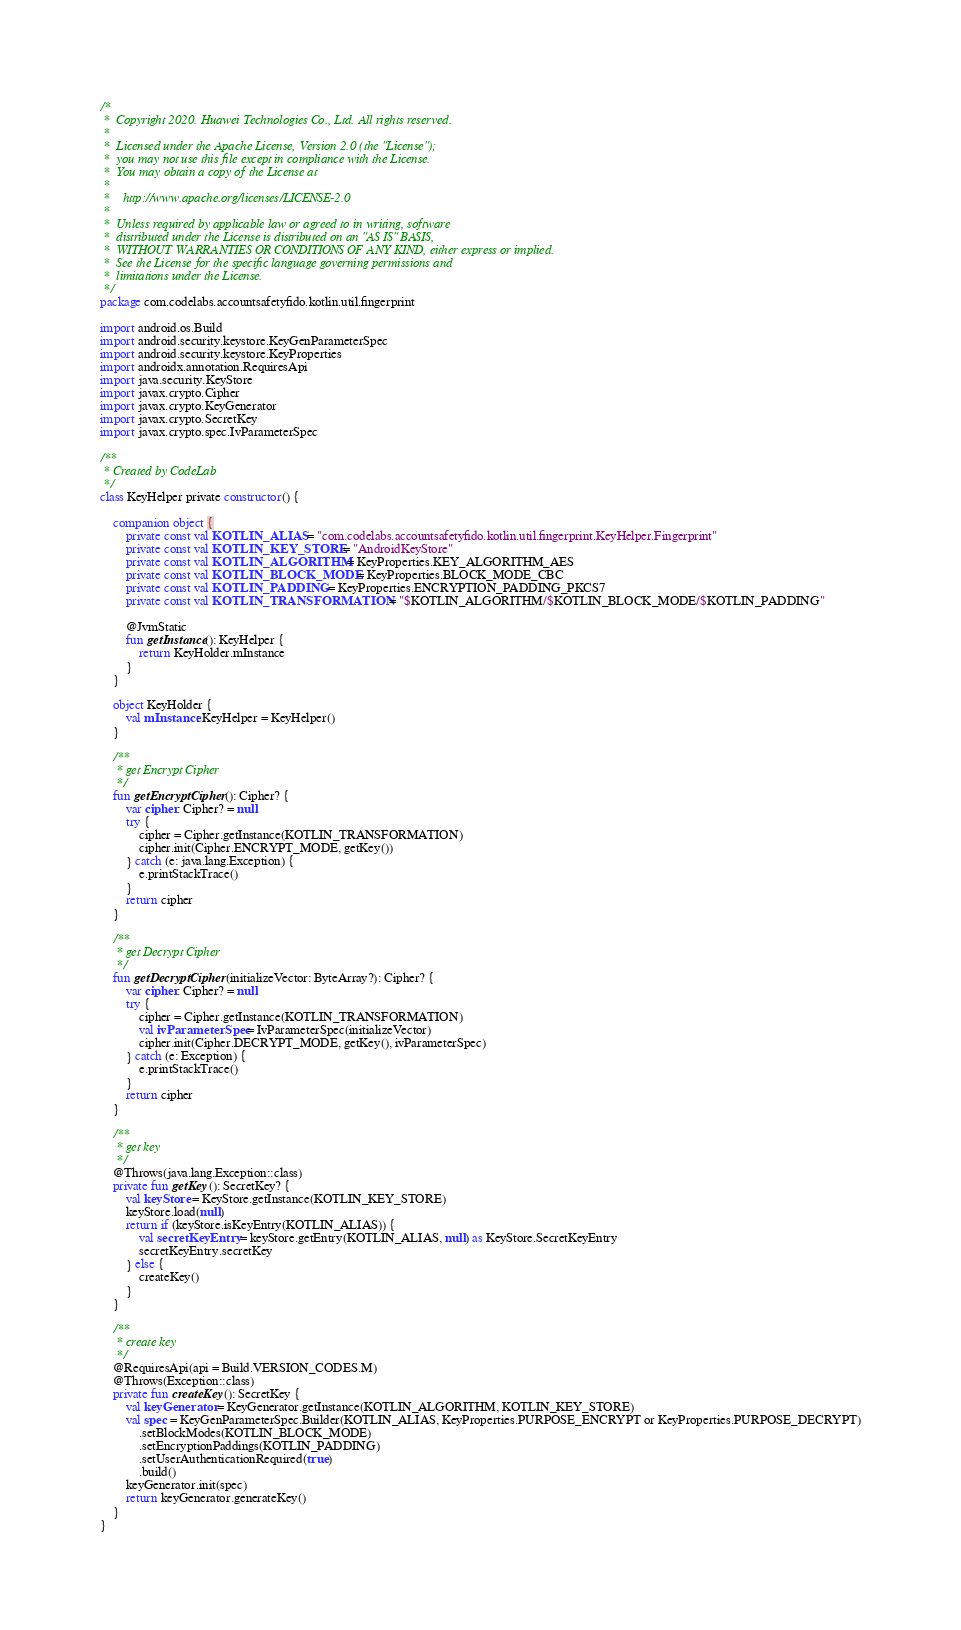Convert code to text. <code><loc_0><loc_0><loc_500><loc_500><_Kotlin_>/*
 *  Copyright 2020. Huawei Technologies Co., Ltd. All rights reserved.
 *
 *  Licensed under the Apache License, Version 2.0 (the "License");
 *  you may not use this file except in compliance with the License.
 *  You may obtain a copy of the License at
 *
 *    http://www.apache.org/licenses/LICENSE-2.0
 *
 *  Unless required by applicable law or agreed to in writing, software
 *  distributed under the License is distributed on an "AS IS" BASIS,
 *  WITHOUT WARRANTIES OR CONDITIONS OF ANY KIND, either express or implied.
 *  See the License for the specific language governing permissions and
 *  limitations under the License.
 */
package com.codelabs.accountsafetyfido.kotlin.util.fingerprint

import android.os.Build
import android.security.keystore.KeyGenParameterSpec
import android.security.keystore.KeyProperties
import androidx.annotation.RequiresApi
import java.security.KeyStore
import javax.crypto.Cipher
import javax.crypto.KeyGenerator
import javax.crypto.SecretKey
import javax.crypto.spec.IvParameterSpec

/**
 * Created by CodeLab
 */
class KeyHelper private constructor() {

    companion object {
        private const val KOTLIN_ALIAS = "com.codelabs.accountsafetyfido.kotlin.util.fingerprint.KeyHelper.Fingerprint"
        private const val KOTLIN_KEY_STORE = "AndroidKeyStore"
        private const val KOTLIN_ALGORITHM = KeyProperties.KEY_ALGORITHM_AES
        private const val KOTLIN_BLOCK_MODE = KeyProperties.BLOCK_MODE_CBC
        private const val KOTLIN_PADDING = KeyProperties.ENCRYPTION_PADDING_PKCS7
        private const val KOTLIN_TRANSFORMATION = "$KOTLIN_ALGORITHM/$KOTLIN_BLOCK_MODE/$KOTLIN_PADDING"

        @JvmStatic
        fun getInstance(): KeyHelper {
            return KeyHolder.mInstance
        }
    }

    object KeyHolder {
        val mInstance: KeyHelper = KeyHelper()
    }

    /**
     * get Encrypt Cipher
     */
    fun getEncryptCipher(): Cipher? {
        var cipher: Cipher? = null
        try {
            cipher = Cipher.getInstance(KOTLIN_TRANSFORMATION)
            cipher.init(Cipher.ENCRYPT_MODE, getKey())
        } catch (e: java.lang.Exception) {
            e.printStackTrace()
        }
        return cipher
    }

    /**
     * get Decrypt Cipher
     */
    fun getDecryptCipher(initializeVector: ByteArray?): Cipher? {
        var cipher: Cipher? = null
        try {
            cipher = Cipher.getInstance(KOTLIN_TRANSFORMATION)
            val ivParameterSpec = IvParameterSpec(initializeVector)
            cipher.init(Cipher.DECRYPT_MODE, getKey(), ivParameterSpec)
        } catch (e: Exception) {
            e.printStackTrace()
        }
        return cipher
    }

    /**
     * get key
     */
    @Throws(java.lang.Exception::class)
    private fun getKey(): SecretKey? {
        val keyStore = KeyStore.getInstance(KOTLIN_KEY_STORE)
        keyStore.load(null)
        return if (keyStore.isKeyEntry(KOTLIN_ALIAS)) {
            val secretKeyEntry = keyStore.getEntry(KOTLIN_ALIAS, null) as KeyStore.SecretKeyEntry
            secretKeyEntry.secretKey
        } else {
            createKey()
        }
    }

    /**
     * create key
     */
    @RequiresApi(api = Build.VERSION_CODES.M)
    @Throws(Exception::class)
    private fun createKey(): SecretKey {
        val keyGenerator = KeyGenerator.getInstance(KOTLIN_ALGORITHM, KOTLIN_KEY_STORE)
        val spec = KeyGenParameterSpec.Builder(KOTLIN_ALIAS, KeyProperties.PURPOSE_ENCRYPT or KeyProperties.PURPOSE_DECRYPT)
            .setBlockModes(KOTLIN_BLOCK_MODE)
            .setEncryptionPaddings(KOTLIN_PADDING)
            .setUserAuthenticationRequired(true)
            .build()
        keyGenerator.init(spec)
        return keyGenerator.generateKey()
    }
}</code> 